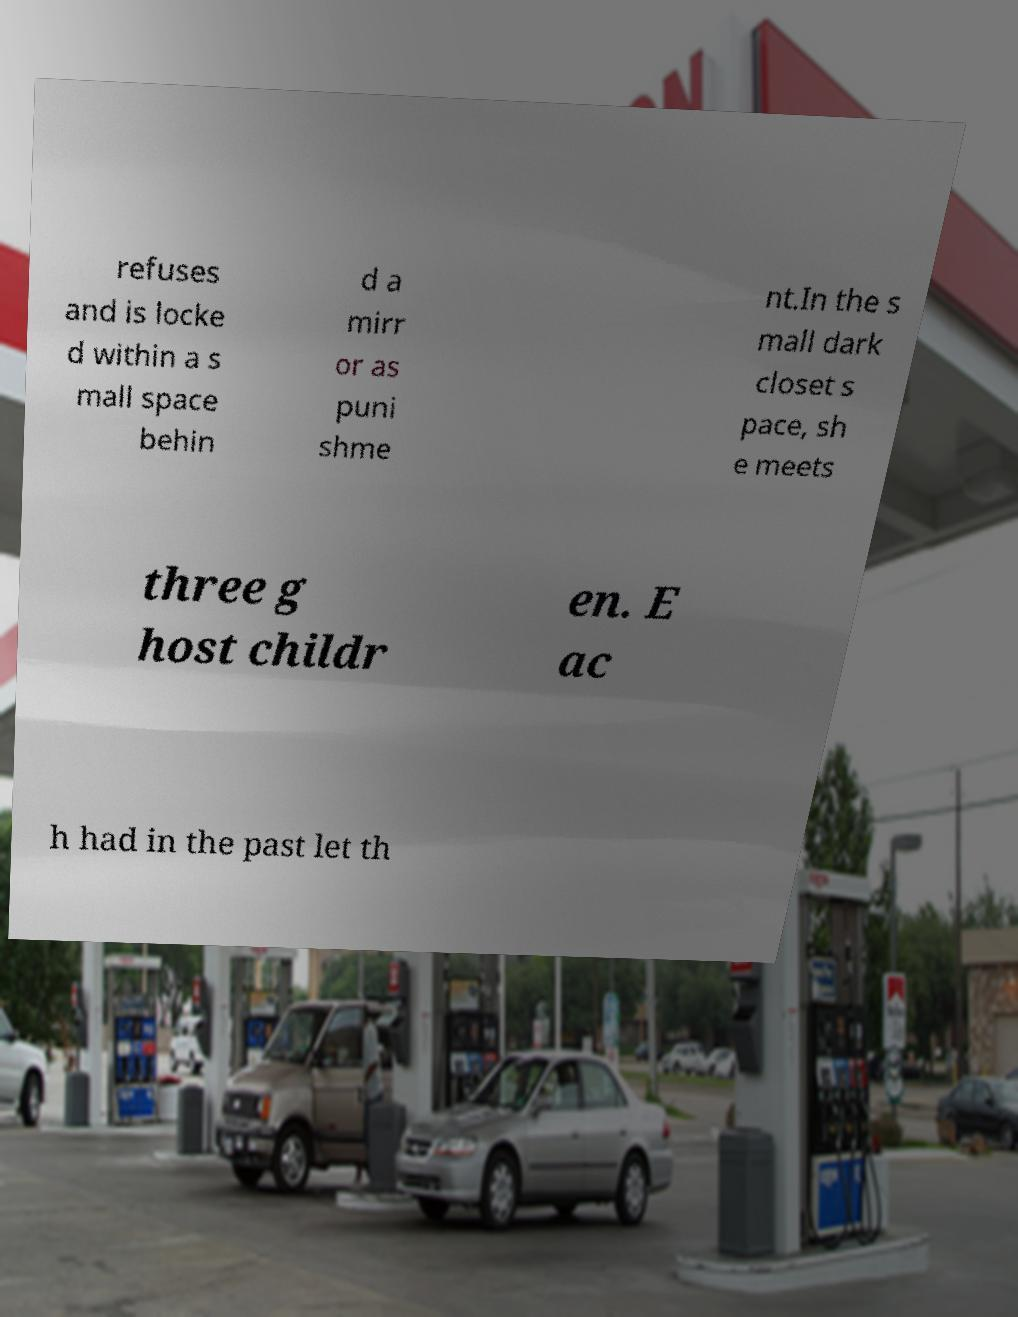Please identify and transcribe the text found in this image. refuses and is locke d within a s mall space behin d a mirr or as puni shme nt.In the s mall dark closet s pace, sh e meets three g host childr en. E ac h had in the past let th 